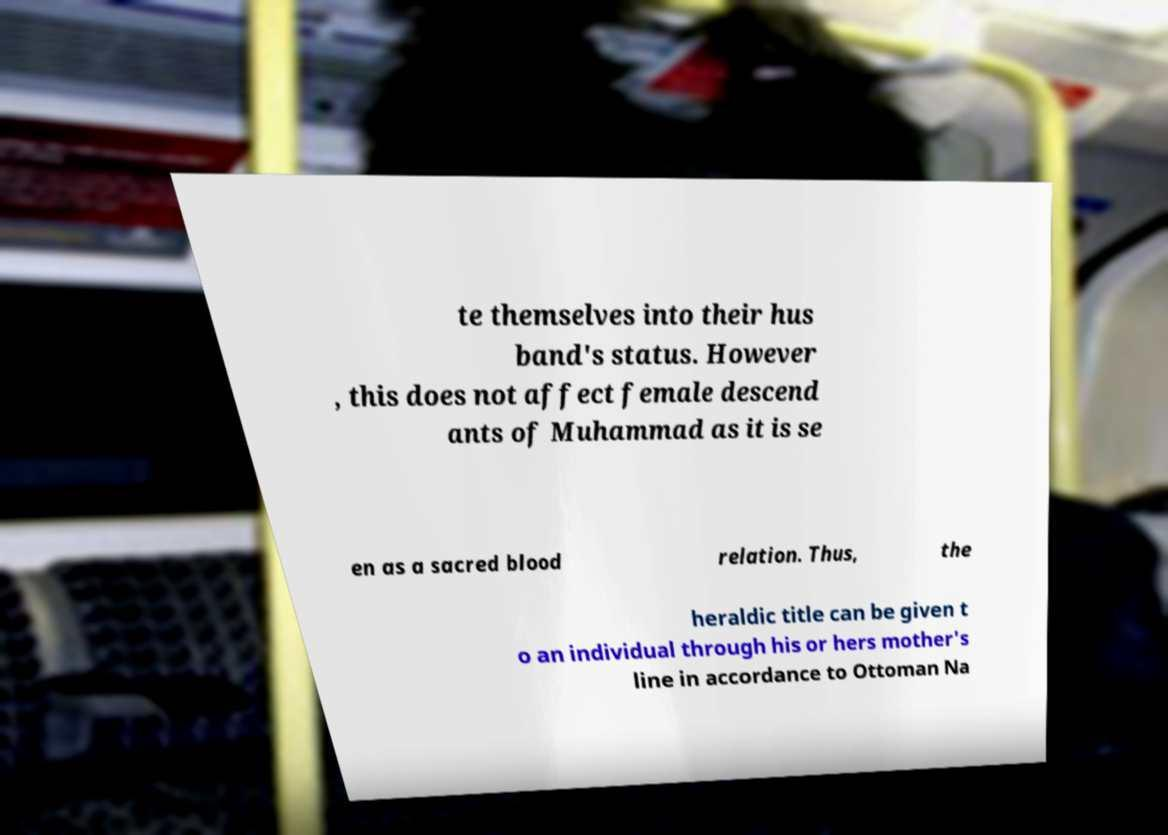Could you extract and type out the text from this image? te themselves into their hus band's status. However , this does not affect female descend ants of Muhammad as it is se en as a sacred blood relation. Thus, the heraldic title can be given t o an individual through his or hers mother's line in accordance to Ottoman Na 